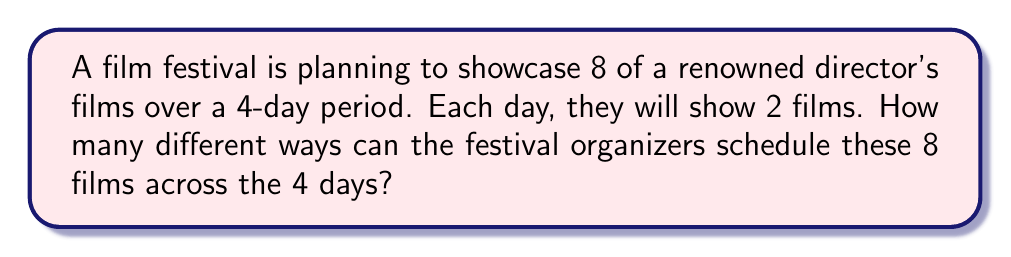Give your solution to this math problem. Let's approach this step-by-step:

1) First, we need to choose which 8 films out of the director's filmography will be shown. However, this is already given in the question, so we don't need to calculate combinations for this.

2) Now, we need to distribute these 8 films across 4 days, with 2 films per day. This is a partition problem.

3) We can solve this using the following steps:
   a) Choose 2 films for the first day: $\binom{8}{2}$
   b) Choose 2 films for the second day from the remaining 6: $\binom{6}{2}$
   c) Choose 2 films for the third day from the remaining 4: $\binom{4}{2}$
   d) The last 2 films will automatically be shown on the fourth day.

4) Multiply these choices together:

   $$\binom{8}{2} \cdot \binom{6}{2} \cdot \binom{4}{2} \cdot \binom{2}{2}$$

5) Calculate each combination:
   $$\binom{8}{2} = 28$$
   $$\binom{6}{2} = 15$$
   $$\binom{4}{2} = 6$$
   $$\binom{2}{2} = 1$$

6) Multiply these results:
   $$28 \cdot 15 \cdot 6 \cdot 1 = 2520$$

Therefore, there are 2520 different ways to schedule the 8 films across the 4 days.
Answer: 2520 